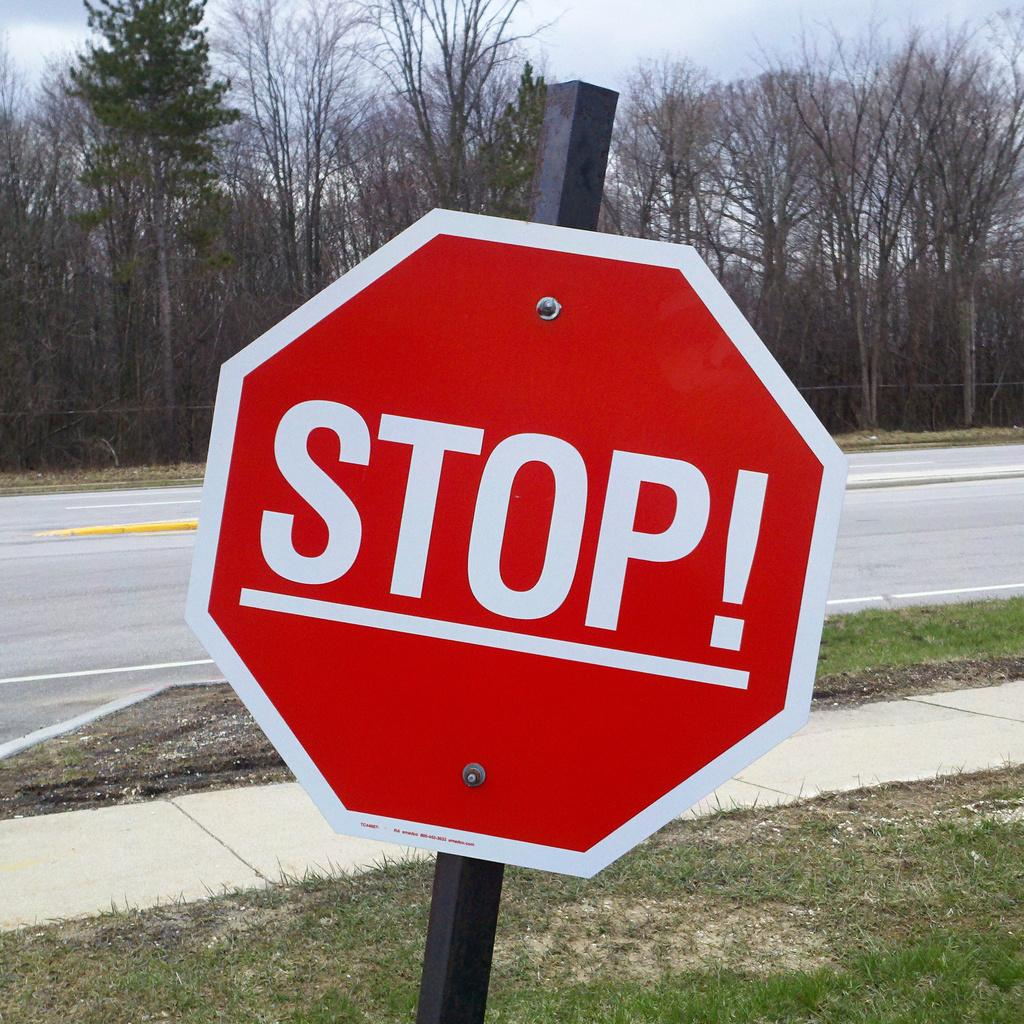<image>
Share a concise interpretation of the image provided. A stop sign has the addition of an exclamation point on it. 